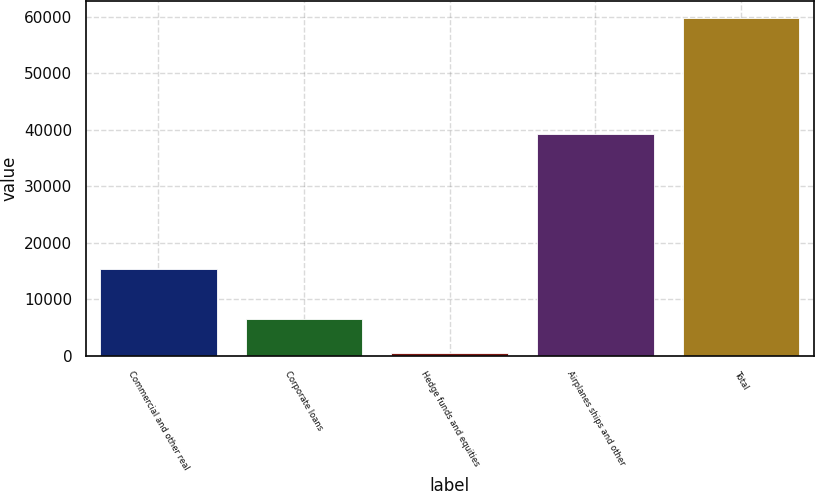Convert chart to OTSL. <chart><loc_0><loc_0><loc_500><loc_500><bar_chart><fcel>Commercial and other real<fcel>Corporate loans<fcel>Hedge funds and equities<fcel>Airplanes ships and other<fcel>Total<nl><fcel>15370<fcel>6471.7<fcel>542<fcel>39202<fcel>59839<nl></chart> 